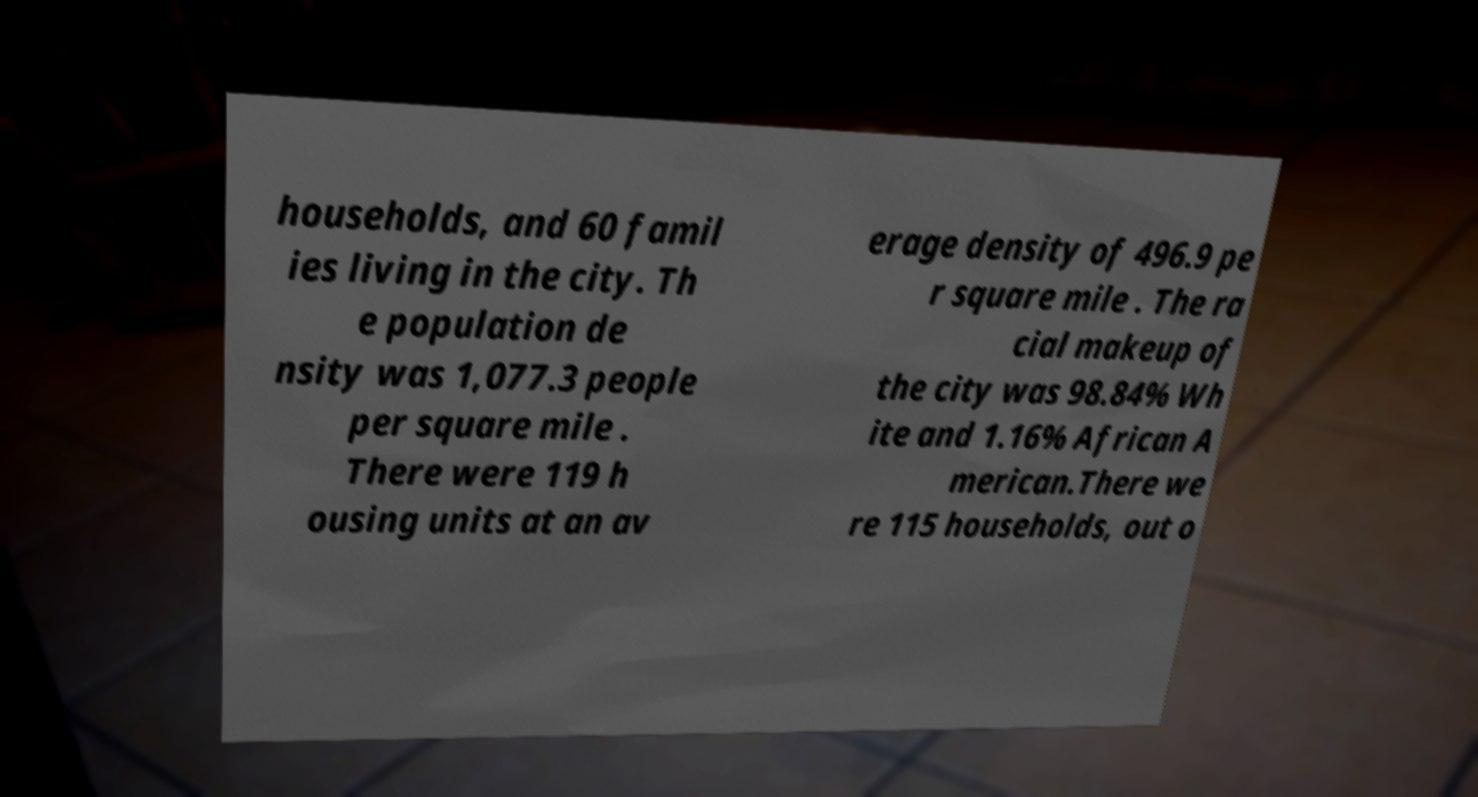There's text embedded in this image that I need extracted. Can you transcribe it verbatim? households, and 60 famil ies living in the city. Th e population de nsity was 1,077.3 people per square mile . There were 119 h ousing units at an av erage density of 496.9 pe r square mile . The ra cial makeup of the city was 98.84% Wh ite and 1.16% African A merican.There we re 115 households, out o 